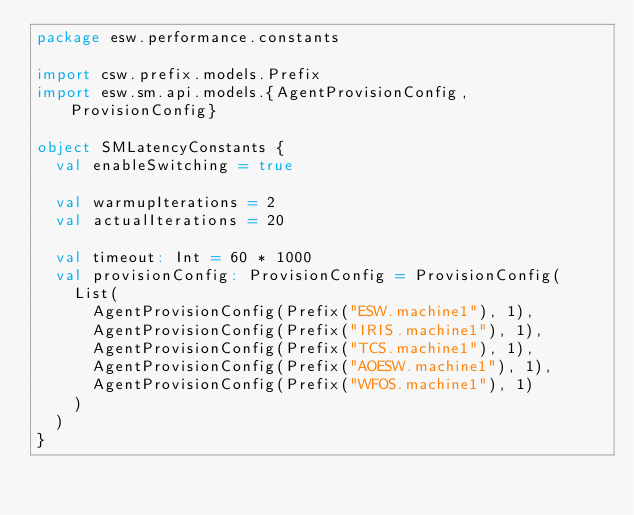Convert code to text. <code><loc_0><loc_0><loc_500><loc_500><_Scala_>package esw.performance.constants

import csw.prefix.models.Prefix
import esw.sm.api.models.{AgentProvisionConfig, ProvisionConfig}

object SMLatencyConstants {
  val enableSwitching = true

  val warmupIterations = 2
  val actualIterations = 20

  val timeout: Int = 60 * 1000
  val provisionConfig: ProvisionConfig = ProvisionConfig(
    List(
      AgentProvisionConfig(Prefix("ESW.machine1"), 1),
      AgentProvisionConfig(Prefix("IRIS.machine1"), 1),
      AgentProvisionConfig(Prefix("TCS.machine1"), 1),
      AgentProvisionConfig(Prefix("AOESW.machine1"), 1),
      AgentProvisionConfig(Prefix("WFOS.machine1"), 1)
    )
  )
}
</code> 